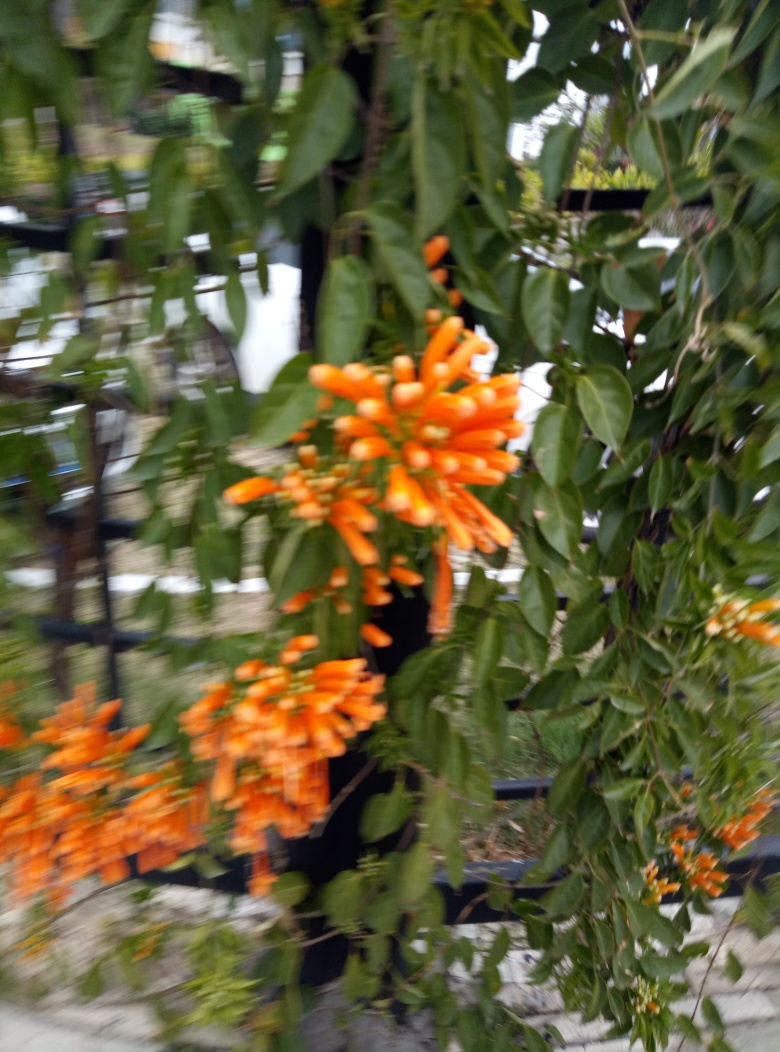What species do these flowers belong to, and where are they commonly found? These orange trumpet-shaped flowers resemble those of the Pyrostegia venusta, commonly known as the flame vine. They are native to Brazil but can be found in various tropical and subtropical regions around the world. Are these flowers significant for local wildlife? Yes, flowers like these often play a vital role in local ecosystems. Their bright color and rich nectar are particularly attractive to pollinators such as birds, bees, and butterflies, making them important contributors to their habitats. 